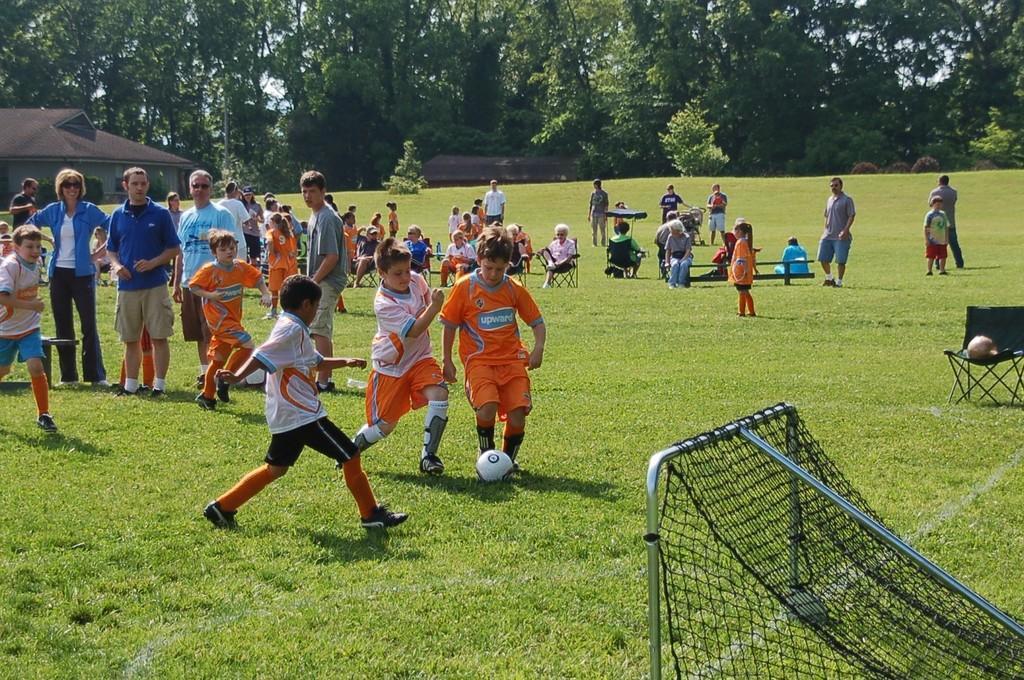How would you summarize this image in a sentence or two? In this image there are group of persons who are sitting and playing at the right side of the image there is a net and at the background of the image there are trees. 